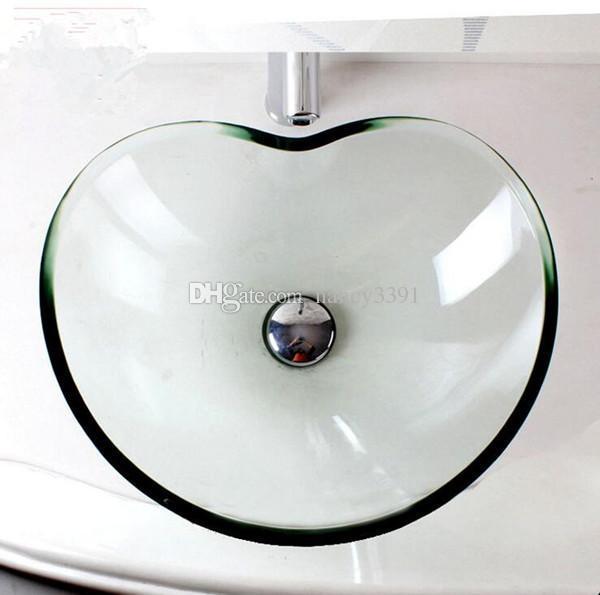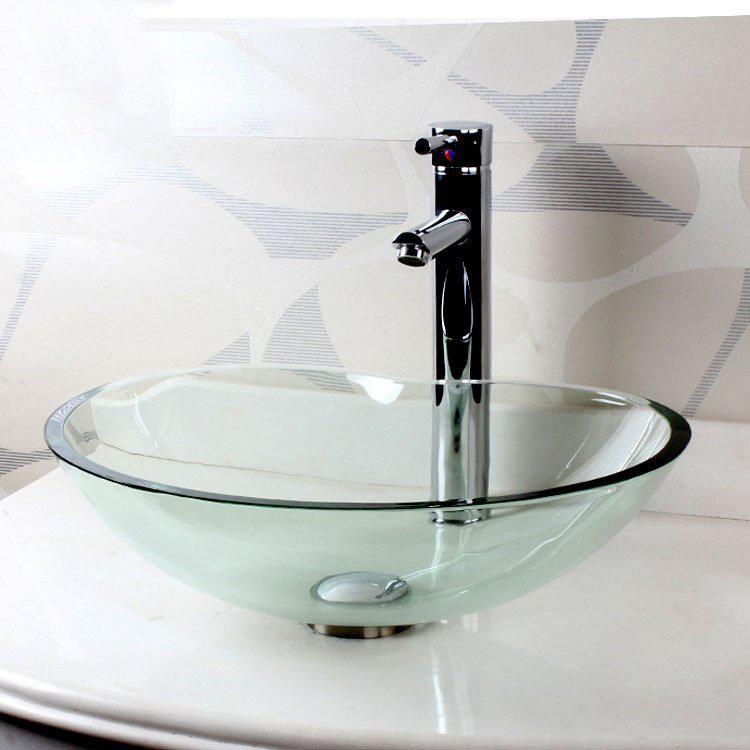The first image is the image on the left, the second image is the image on the right. Given the left and right images, does the statement "At least one image contains a transparent wash basin." hold true? Answer yes or no. Yes. 